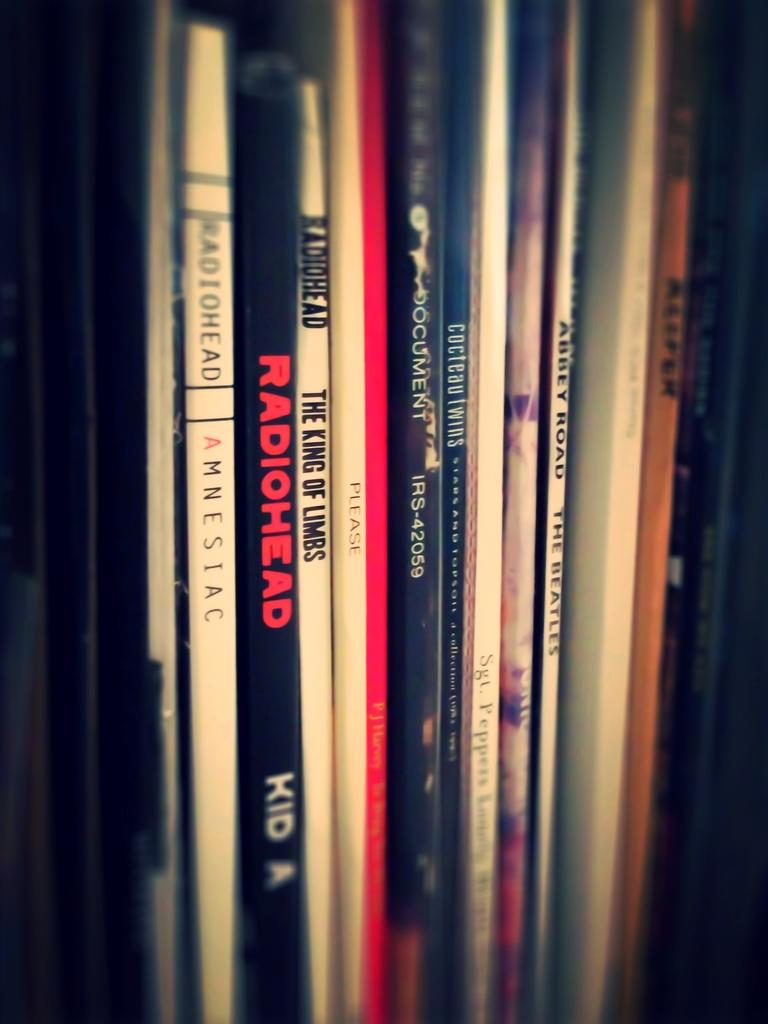<image>
Present a compact description of the photo's key features. A row of music CDs include titles by Radiohead and the Beatles. 